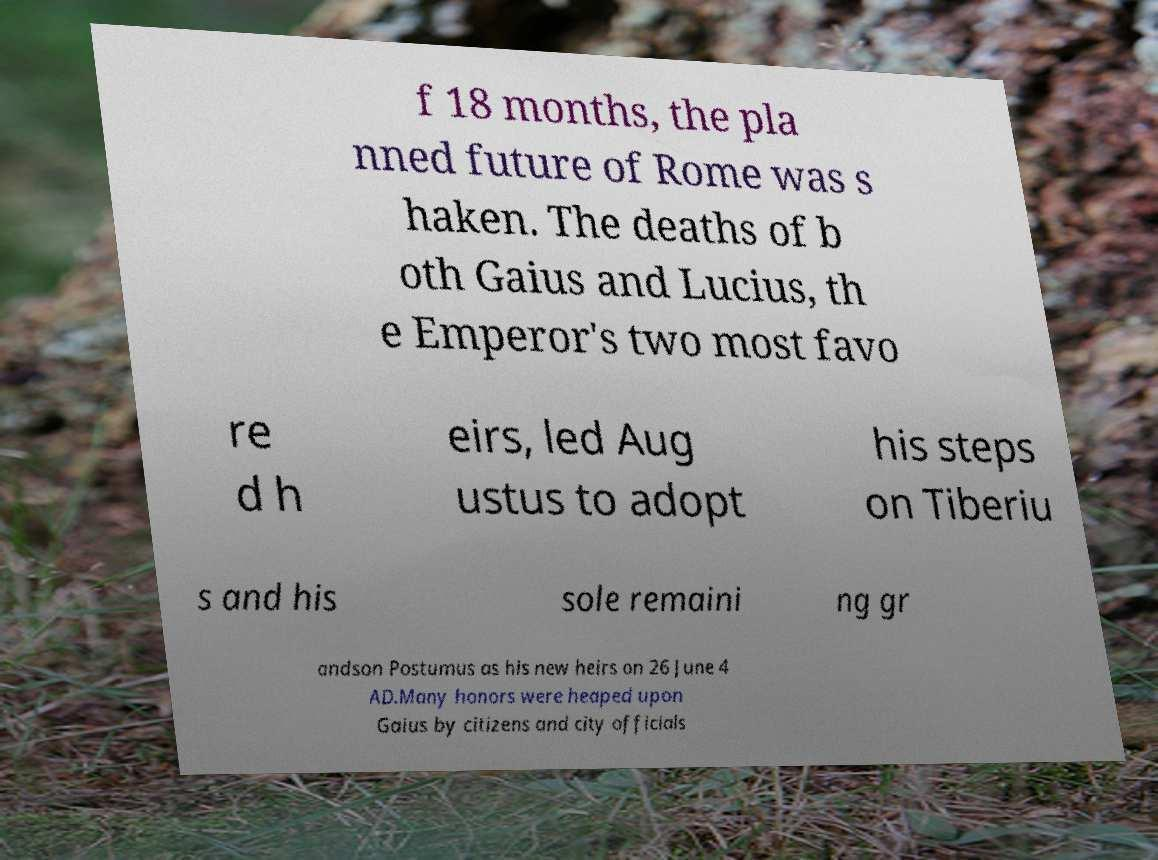Could you extract and type out the text from this image? f 18 months, the pla nned future of Rome was s haken. The deaths of b oth Gaius and Lucius, th e Emperor's two most favo re d h eirs, led Aug ustus to adopt his steps on Tiberiu s and his sole remaini ng gr andson Postumus as his new heirs on 26 June 4 AD.Many honors were heaped upon Gaius by citizens and city officials 